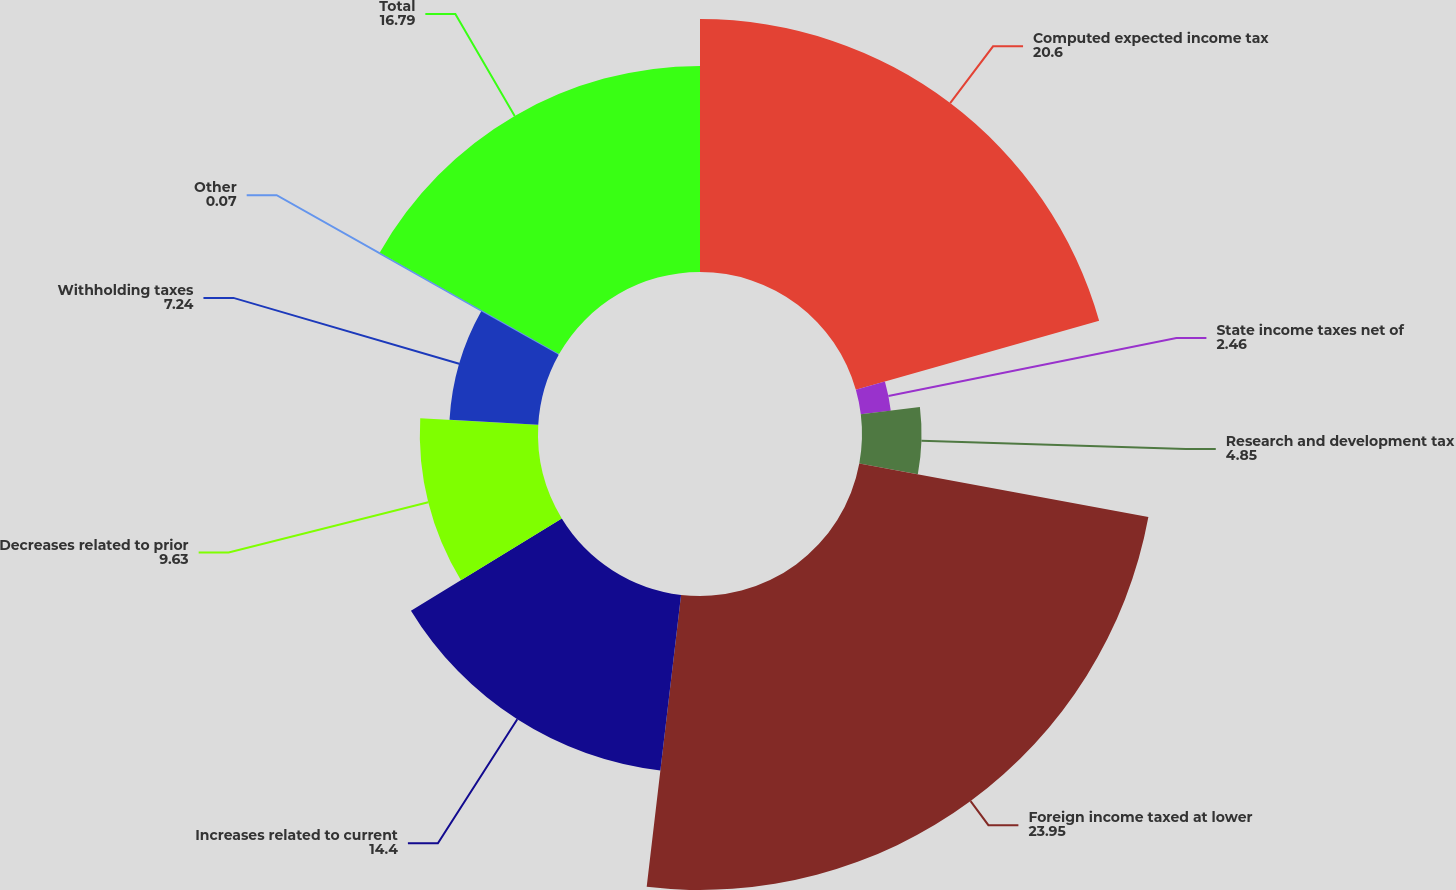<chart> <loc_0><loc_0><loc_500><loc_500><pie_chart><fcel>Computed expected income tax<fcel>State income taxes net of<fcel>Research and development tax<fcel>Foreign income taxed at lower<fcel>Increases related to current<fcel>Decreases related to prior<fcel>Withholding taxes<fcel>Other<fcel>Total<nl><fcel>20.6%<fcel>2.46%<fcel>4.85%<fcel>23.95%<fcel>14.4%<fcel>9.63%<fcel>7.24%<fcel>0.07%<fcel>16.79%<nl></chart> 